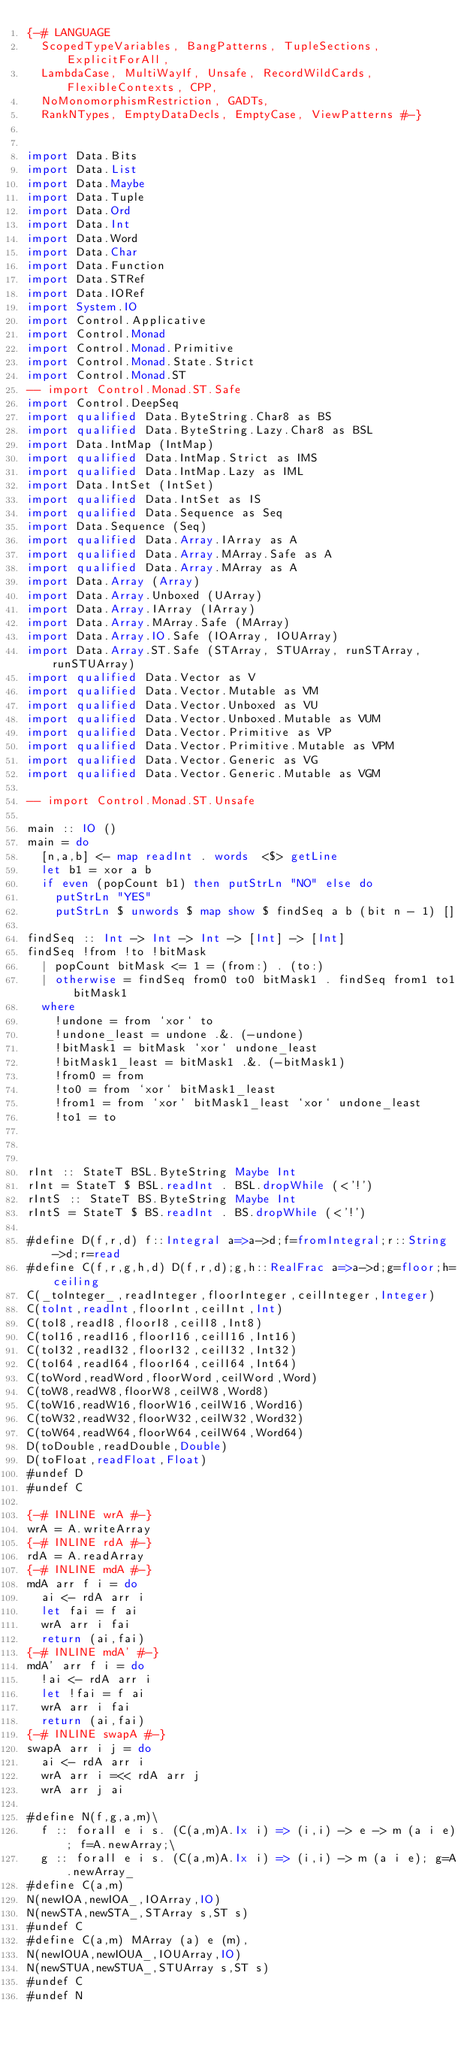<code> <loc_0><loc_0><loc_500><loc_500><_Haskell_>{-# LANGUAGE
  ScopedTypeVariables, BangPatterns, TupleSections, ExplicitForAll,
  LambdaCase, MultiWayIf, Unsafe, RecordWildCards, FlexibleContexts, CPP,
  NoMonomorphismRestriction, GADTs,
  RankNTypes, EmptyDataDecls, EmptyCase, ViewPatterns #-}


import Data.Bits
import Data.List
import Data.Maybe
import Data.Tuple
import Data.Ord
import Data.Int
import Data.Word
import Data.Char
import Data.Function
import Data.STRef
import Data.IORef
import System.IO
import Control.Applicative
import Control.Monad
import Control.Monad.Primitive
import Control.Monad.State.Strict
import Control.Monad.ST
-- import Control.Monad.ST.Safe
import Control.DeepSeq
import qualified Data.ByteString.Char8 as BS
import qualified Data.ByteString.Lazy.Char8 as BSL
import Data.IntMap (IntMap)
import qualified Data.IntMap.Strict as IMS
import qualified Data.IntMap.Lazy as IML
import Data.IntSet (IntSet)
import qualified Data.IntSet as IS
import qualified Data.Sequence as Seq
import Data.Sequence (Seq)
import qualified Data.Array.IArray as A
import qualified Data.Array.MArray.Safe as A
import qualified Data.Array.MArray as A
import Data.Array (Array)
import Data.Array.Unboxed (UArray)
import Data.Array.IArray (IArray)
import Data.Array.MArray.Safe (MArray)
import Data.Array.IO.Safe (IOArray, IOUArray)
import Data.Array.ST.Safe (STArray, STUArray, runSTArray, runSTUArray)
import qualified Data.Vector as V
import qualified Data.Vector.Mutable as VM
import qualified Data.Vector.Unboxed as VU
import qualified Data.Vector.Unboxed.Mutable as VUM
import qualified Data.Vector.Primitive as VP
import qualified Data.Vector.Primitive.Mutable as VPM
import qualified Data.Vector.Generic as VG
import qualified Data.Vector.Generic.Mutable as VGM

-- import Control.Monad.ST.Unsafe

main :: IO ()
main = do
  [n,a,b] <- map readInt . words  <$> getLine
  let b1 = xor a b
  if even (popCount b1) then putStrLn "NO" else do
    putStrLn "YES"
    putStrLn $ unwords $ map show $ findSeq a b (bit n - 1) []

findSeq :: Int -> Int -> Int -> [Int] -> [Int]
findSeq !from !to !bitMask
  | popCount bitMask <= 1 = (from:) . (to:)
  | otherwise = findSeq from0 to0 bitMask1 . findSeq from1 to1 bitMask1
  where
    !undone = from `xor` to
    !undone_least = undone .&. (-undone)
    !bitMask1 = bitMask `xor` undone_least
    !bitMask1_least = bitMask1 .&. (-bitMask1)
    !from0 = from
    !to0 = from `xor` bitMask1_least
    !from1 = from `xor` bitMask1_least `xor` undone_least
    !to1 = to
    


rInt :: StateT BSL.ByteString Maybe Int
rInt = StateT $ BSL.readInt . BSL.dropWhile (<'!')
rIntS :: StateT BS.ByteString Maybe Int
rIntS = StateT $ BS.readInt . BS.dropWhile (<'!')

#define D(f,r,d) f::Integral a=>a->d;f=fromIntegral;r::String->d;r=read
#define C(f,r,g,h,d) D(f,r,d);g,h::RealFrac a=>a->d;g=floor;h=ceiling
C(_toInteger_,readInteger,floorInteger,ceilInteger,Integer)
C(toInt,readInt,floorInt,ceilInt,Int)
C(toI8,readI8,floorI8,ceilI8,Int8)
C(toI16,readI16,floorI16,ceilI16,Int16)
C(toI32,readI32,floorI32,ceilI32,Int32)
C(toI64,readI64,floorI64,ceilI64,Int64)
C(toWord,readWord,floorWord,ceilWord,Word)
C(toW8,readW8,floorW8,ceilW8,Word8)
C(toW16,readW16,floorW16,ceilW16,Word16)
C(toW32,readW32,floorW32,ceilW32,Word32)
C(toW64,readW64,floorW64,ceilW64,Word64)
D(toDouble,readDouble,Double)
D(toFloat,readFloat,Float)
#undef D
#undef C

{-# INLINE wrA #-}
wrA = A.writeArray
{-# INLINE rdA #-}
rdA = A.readArray
{-# INLINE mdA #-}
mdA arr f i = do
  ai <- rdA arr i
  let fai = f ai 
  wrA arr i fai
  return (ai,fai)
{-# INLINE mdA' #-}
mdA' arr f i = do
  !ai <- rdA arr i
  let !fai = f ai
  wrA arr i fai
  return (ai,fai)
{-# INLINE swapA #-}
swapA arr i j = do
  ai <- rdA arr i
  wrA arr i =<< rdA arr j
  wrA arr j ai

#define N(f,g,a,m)\
  f :: forall e i s. (C(a,m)A.Ix i) => (i,i) -> e -> m (a i e); f=A.newArray;\
  g :: forall e i s. (C(a,m)A.Ix i) => (i,i) -> m (a i e); g=A.newArray_
#define C(a,m)
N(newIOA,newIOA_,IOArray,IO)
N(newSTA,newSTA_,STArray s,ST s)
#undef C
#define C(a,m) MArray (a) e (m), 
N(newIOUA,newIOUA_,IOUArray,IO)
N(newSTUA,newSTUA_,STUArray s,ST s)
#undef C
#undef N

</code> 